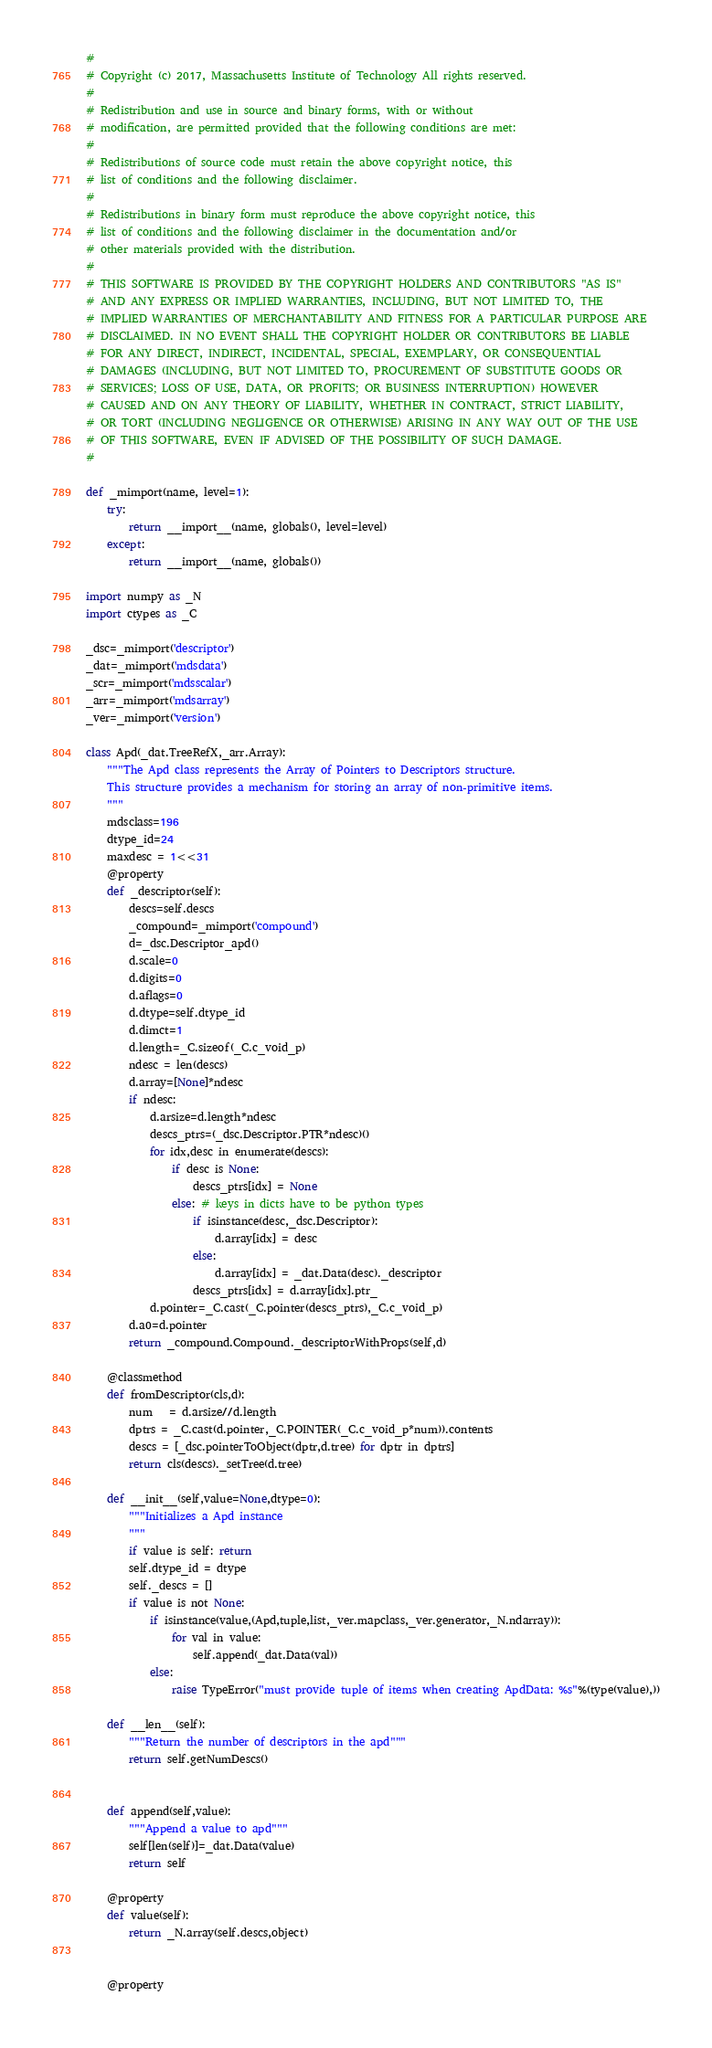Convert code to text. <code><loc_0><loc_0><loc_500><loc_500><_Python_>#
# Copyright (c) 2017, Massachusetts Institute of Technology All rights reserved.
#
# Redistribution and use in source and binary forms, with or without
# modification, are permitted provided that the following conditions are met:
#
# Redistributions of source code must retain the above copyright notice, this
# list of conditions and the following disclaimer.
#
# Redistributions in binary form must reproduce the above copyright notice, this
# list of conditions and the following disclaimer in the documentation and/or
# other materials provided with the distribution.
#
# THIS SOFTWARE IS PROVIDED BY THE COPYRIGHT HOLDERS AND CONTRIBUTORS "AS IS"
# AND ANY EXPRESS OR IMPLIED WARRANTIES, INCLUDING, BUT NOT LIMITED TO, THE
# IMPLIED WARRANTIES OF MERCHANTABILITY AND FITNESS FOR A PARTICULAR PURPOSE ARE
# DISCLAIMED. IN NO EVENT SHALL THE COPYRIGHT HOLDER OR CONTRIBUTORS BE LIABLE
# FOR ANY DIRECT, INDIRECT, INCIDENTAL, SPECIAL, EXEMPLARY, OR CONSEQUENTIAL
# DAMAGES (INCLUDING, BUT NOT LIMITED TO, PROCUREMENT OF SUBSTITUTE GOODS OR
# SERVICES; LOSS OF USE, DATA, OR PROFITS; OR BUSINESS INTERRUPTION) HOWEVER
# CAUSED AND ON ANY THEORY OF LIABILITY, WHETHER IN CONTRACT, STRICT LIABILITY,
# OR TORT (INCLUDING NEGLIGENCE OR OTHERWISE) ARISING IN ANY WAY OUT OF THE USE
# OF THIS SOFTWARE, EVEN IF ADVISED OF THE POSSIBILITY OF SUCH DAMAGE.
#

def _mimport(name, level=1):
    try:
        return __import__(name, globals(), level=level)
    except:
        return __import__(name, globals())

import numpy as _N
import ctypes as _C

_dsc=_mimport('descriptor')
_dat=_mimport('mdsdata')
_scr=_mimport('mdsscalar')
_arr=_mimport('mdsarray')
_ver=_mimport('version')

class Apd(_dat.TreeRefX,_arr.Array):
    """The Apd class represents the Array of Pointers to Descriptors structure.
    This structure provides a mechanism for storing an array of non-primitive items.
    """
    mdsclass=196
    dtype_id=24
    maxdesc = 1<<31
    @property
    def _descriptor(self):
        descs=self.descs
        _compound=_mimport('compound')
        d=_dsc.Descriptor_apd()
        d.scale=0
        d.digits=0
        d.aflags=0
        d.dtype=self.dtype_id
        d.dimct=1
        d.length=_C.sizeof(_C.c_void_p)
        ndesc = len(descs)
        d.array=[None]*ndesc
        if ndesc:
            d.arsize=d.length*ndesc
            descs_ptrs=(_dsc.Descriptor.PTR*ndesc)()
            for idx,desc in enumerate(descs):
                if desc is None:
                    descs_ptrs[idx] = None
                else: # keys in dicts have to be python types
                    if isinstance(desc,_dsc.Descriptor):
                        d.array[idx] = desc
                    else:
                        d.array[idx] = _dat.Data(desc)._descriptor
                    descs_ptrs[idx] = d.array[idx].ptr_
            d.pointer=_C.cast(_C.pointer(descs_ptrs),_C.c_void_p)
        d.a0=d.pointer
        return _compound.Compound._descriptorWithProps(self,d)

    @classmethod
    def fromDescriptor(cls,d):
        num   = d.arsize//d.length
        dptrs = _C.cast(d.pointer,_C.POINTER(_C.c_void_p*num)).contents
        descs = [_dsc.pointerToObject(dptr,d.tree) for dptr in dptrs]
        return cls(descs)._setTree(d.tree)

    def __init__(self,value=None,dtype=0):
        """Initializes a Apd instance
        """
        if value is self: return
        self.dtype_id = dtype
        self._descs = []
        if value is not None:
            if isinstance(value,(Apd,tuple,list,_ver.mapclass,_ver.generator,_N.ndarray)):
                for val in value:
                    self.append(_dat.Data(val))
            else:
                raise TypeError("must provide tuple of items when creating ApdData: %s"%(type(value),))

    def __len__(self):
        """Return the number of descriptors in the apd"""
        return self.getNumDescs()


    def append(self,value):
        """Append a value to apd"""
        self[len(self)]=_dat.Data(value)
        return self

    @property
    def value(self):
        return _N.array(self.descs,object)


    @property</code> 